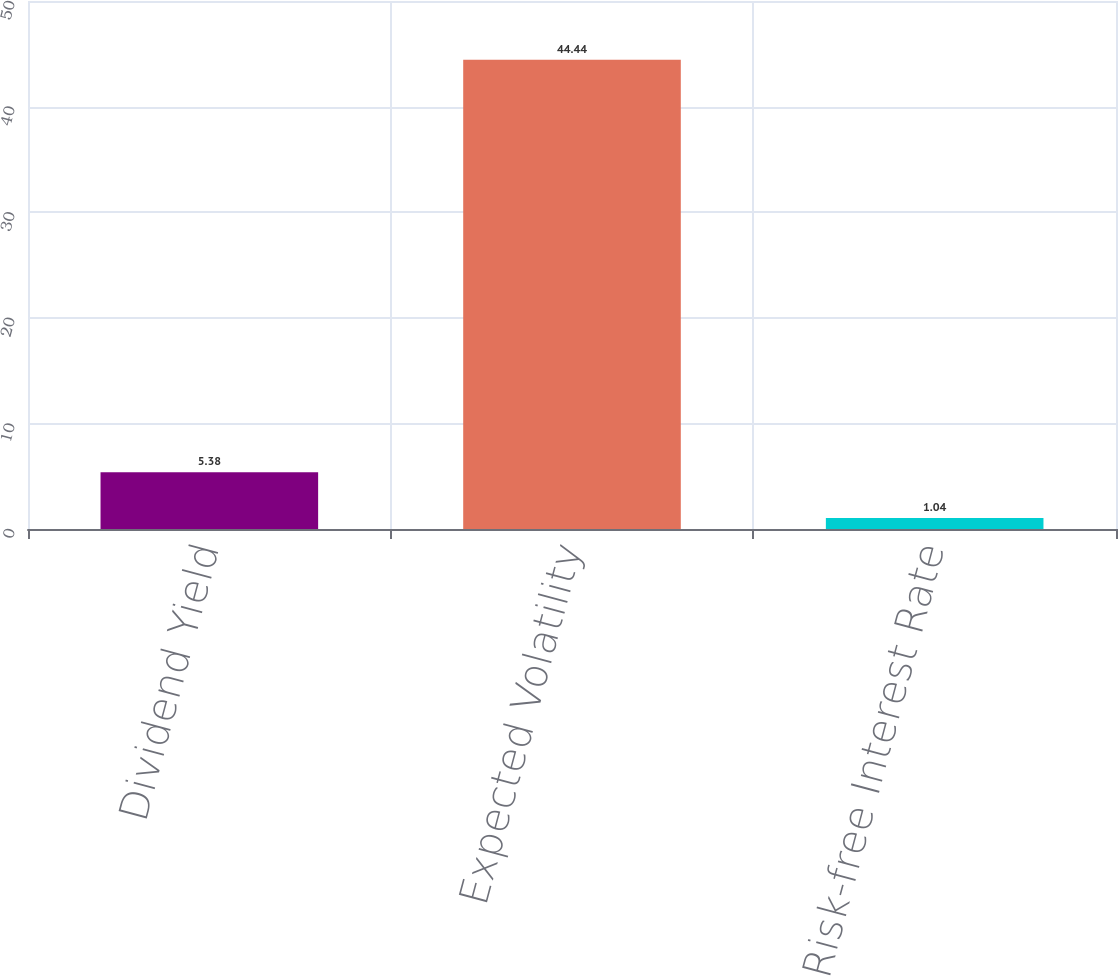Convert chart to OTSL. <chart><loc_0><loc_0><loc_500><loc_500><bar_chart><fcel>Dividend Yield<fcel>Expected Volatility<fcel>Risk-free Interest Rate<nl><fcel>5.38<fcel>44.44<fcel>1.04<nl></chart> 